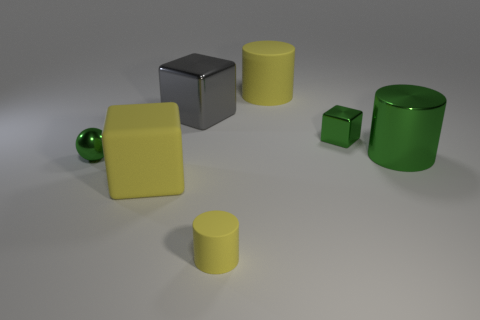Are there any rubber cylinders to the left of the large yellow matte cube?
Make the answer very short. No. Are there more green spheres than yellow things?
Offer a very short reply. No. The big rubber thing in front of the large yellow thing right of the yellow cylinder in front of the shiny cylinder is what color?
Provide a succinct answer. Yellow. What is the color of the sphere that is the same material as the green cylinder?
Provide a succinct answer. Green. Is there any other thing that has the same size as the shiny sphere?
Offer a terse response. Yes. What number of objects are big rubber objects that are behind the large green metal cylinder or large yellow things behind the big green shiny object?
Your answer should be very brief. 1. Do the matte object in front of the large yellow matte cube and the yellow matte cylinder that is behind the small cylinder have the same size?
Your answer should be compact. No. The other big thing that is the same shape as the gray thing is what color?
Provide a succinct answer. Yellow. Is there any other thing that has the same shape as the large green metal thing?
Ensure brevity in your answer.  Yes. Is the number of big matte cubes to the right of the tiny matte cylinder greater than the number of big gray metal objects right of the large gray metal cube?
Provide a short and direct response. No. 